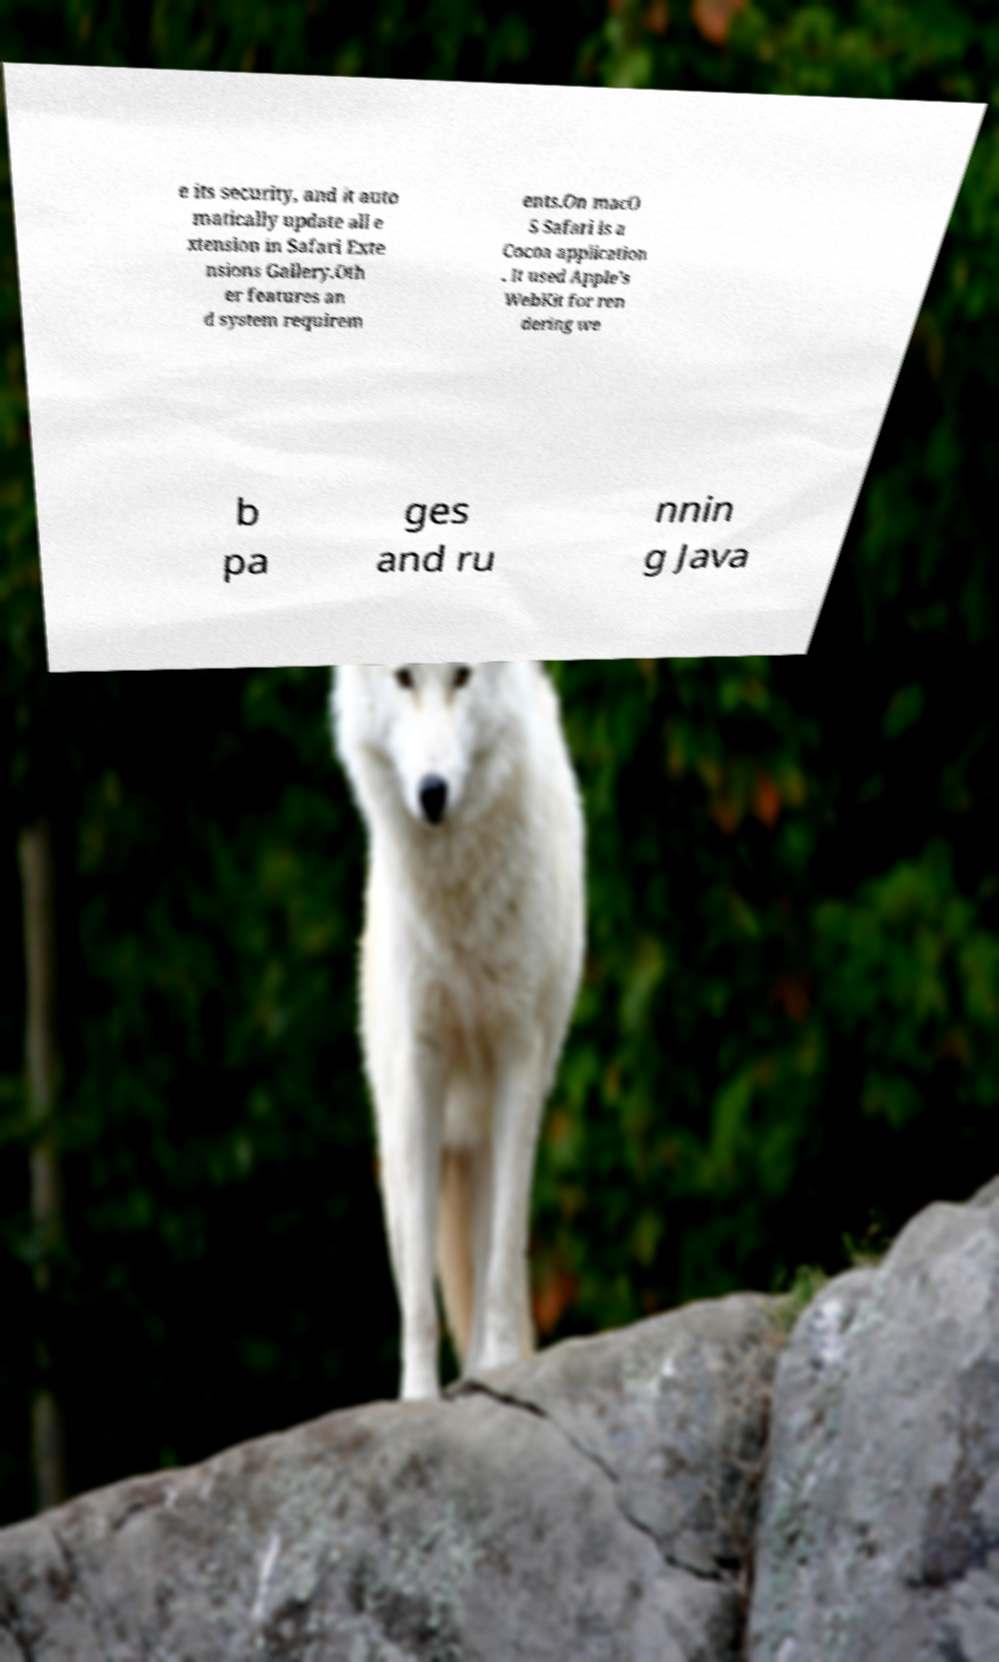Please identify and transcribe the text found in this image. e its security, and it auto matically update all e xtension in Safari Exte nsions Gallery.Oth er features an d system requirem ents.On macO S Safari is a Cocoa application . It used Apple's WebKit for ren dering we b pa ges and ru nnin g Java 